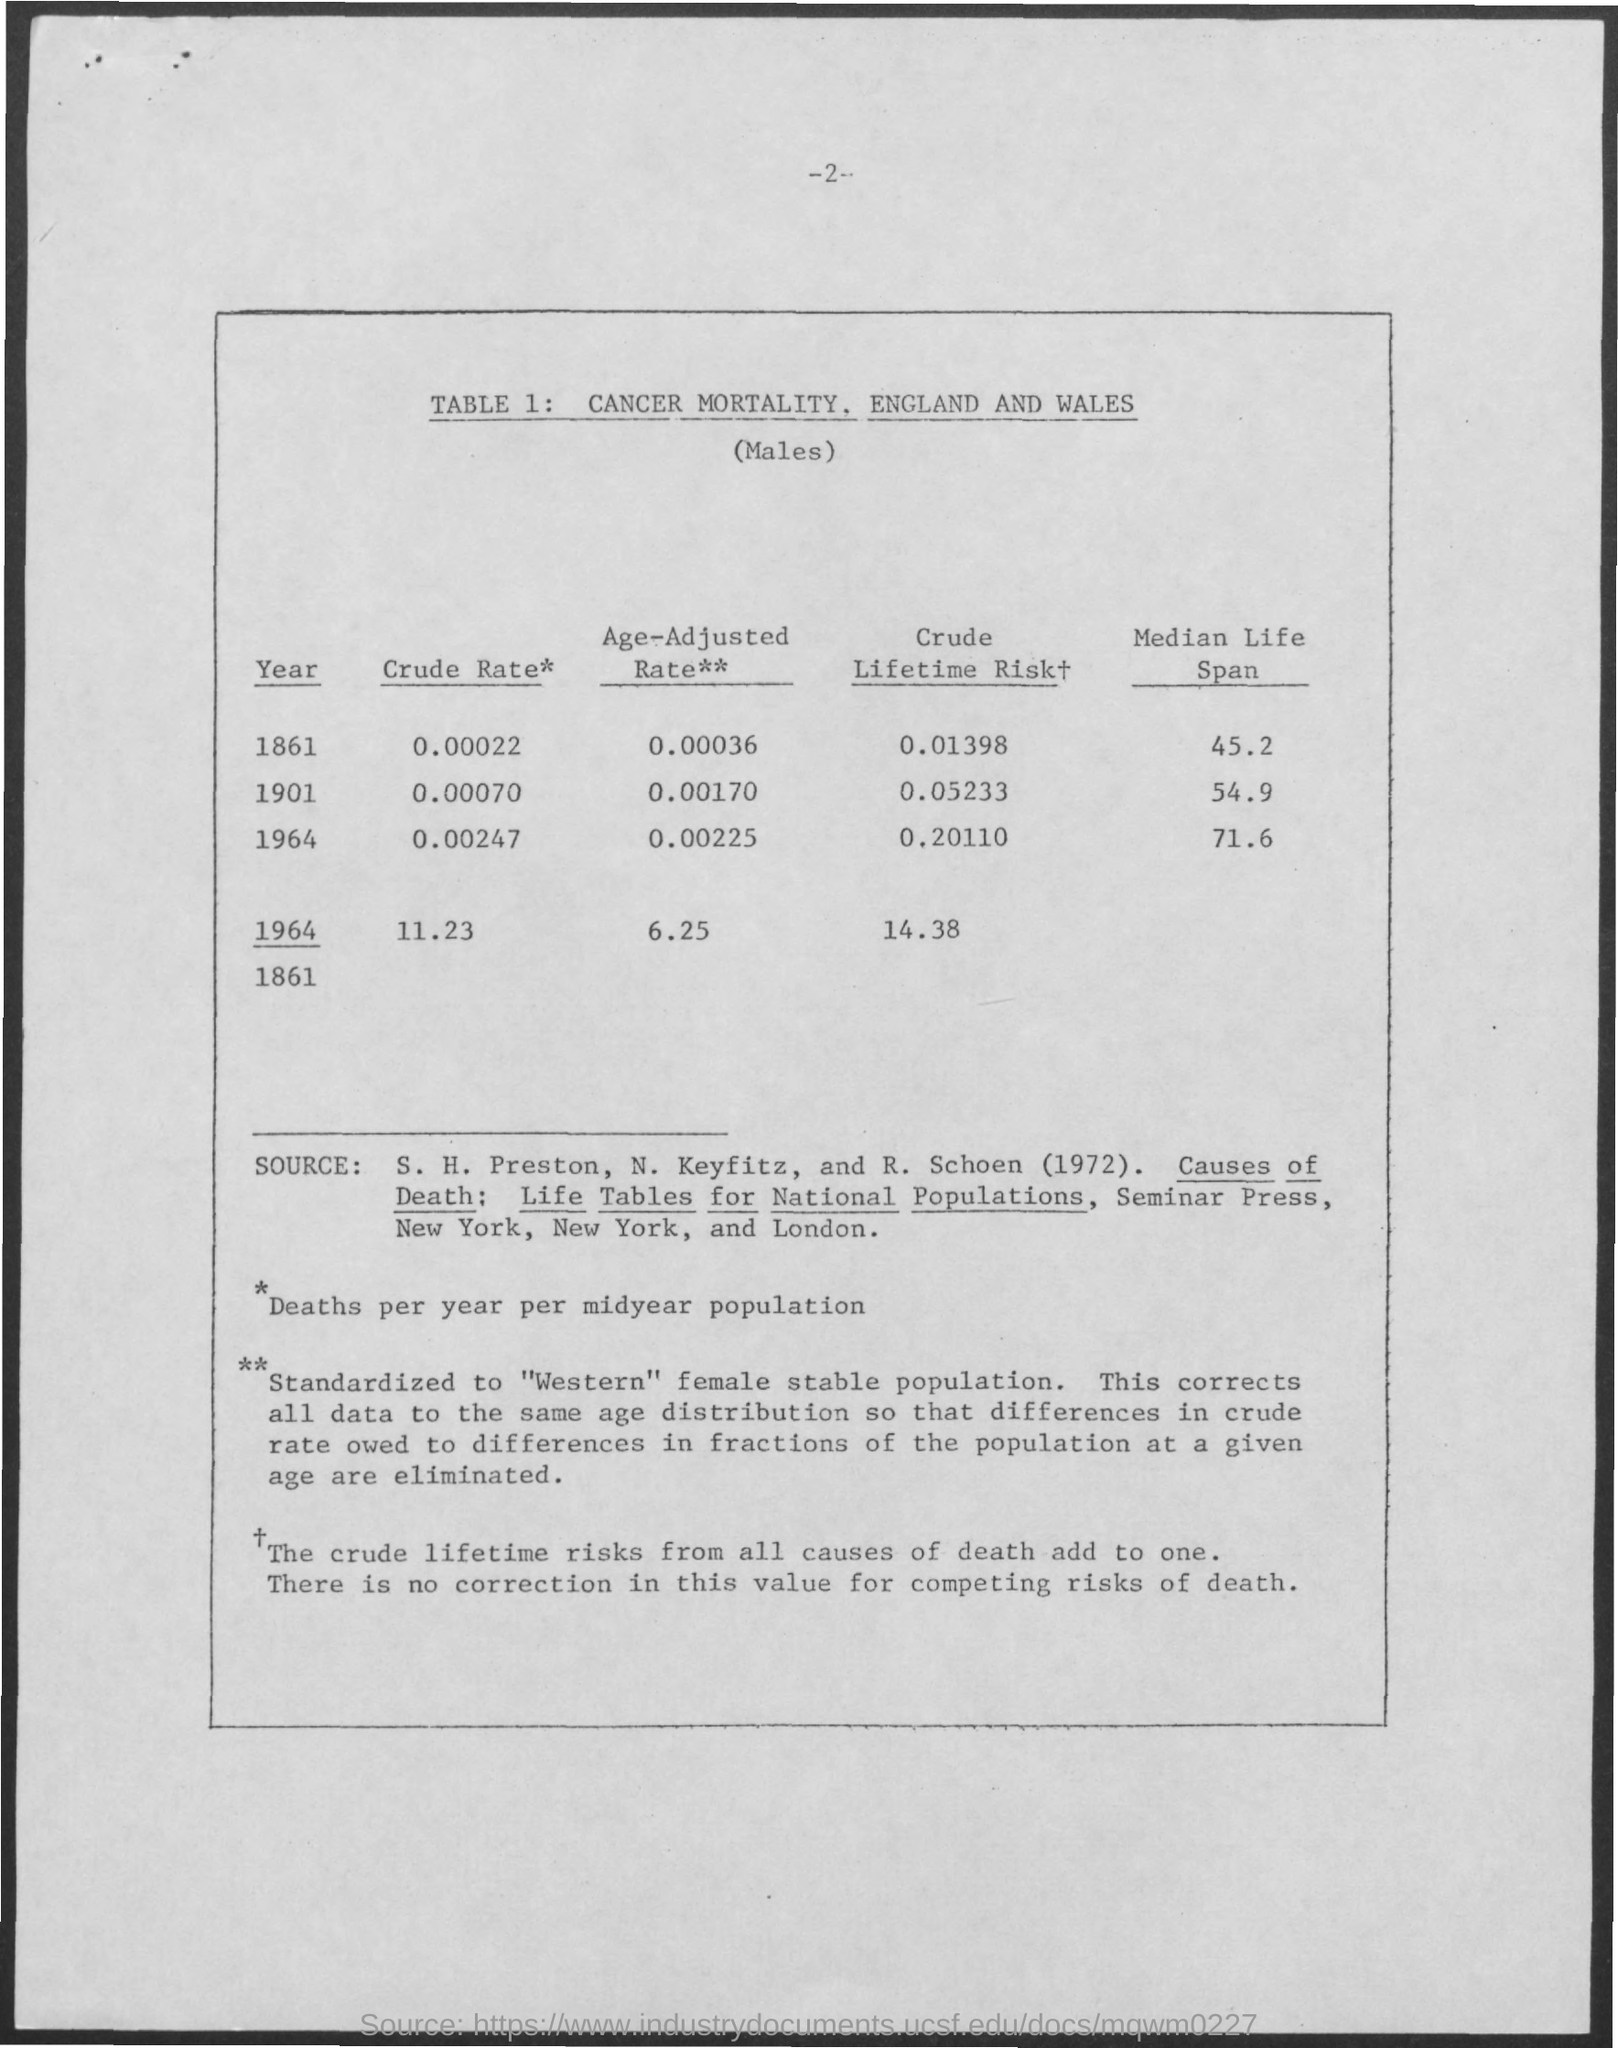What is the Page Number?
Your answer should be very brief. 2. What is the table number?
Keep it short and to the point. 1. What is the median life span in the year 1901?
Make the answer very short. 54.9. What is the median life span in the year 1964?
Your response must be concise. 71.6. What is the age-adjusted rate in the year 1861?
Your answer should be very brief. 0.00036. What is the age-adjusted rate in the year 1901?
Provide a succinct answer. 0.00170. 